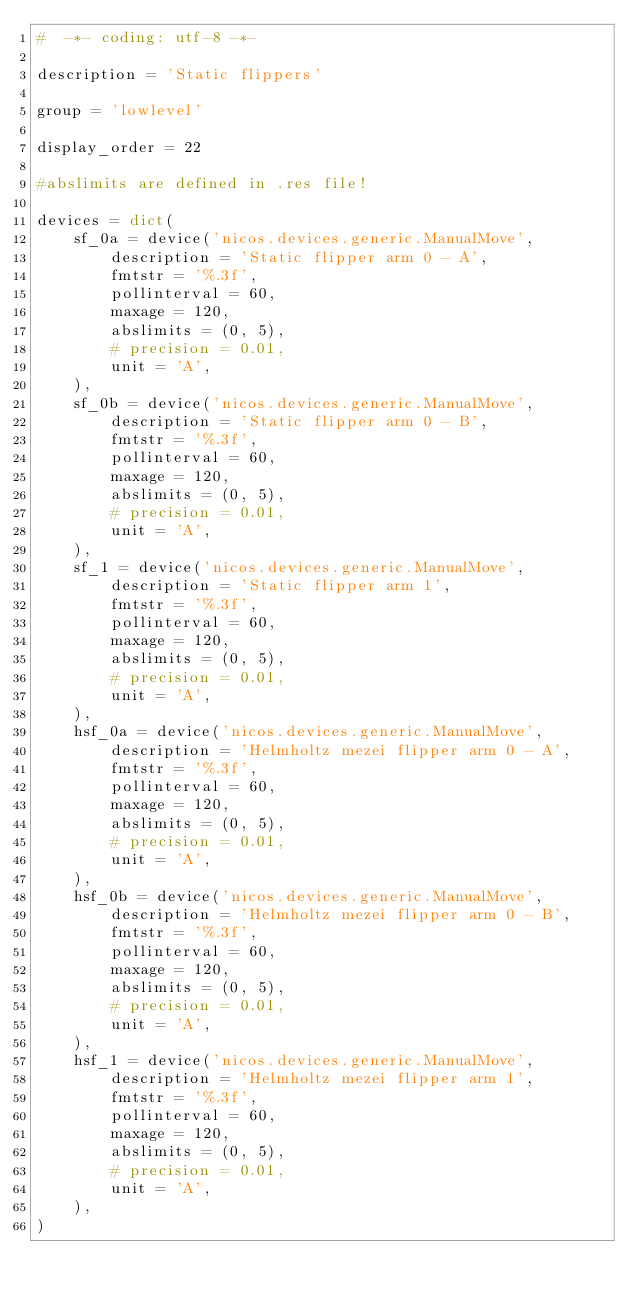<code> <loc_0><loc_0><loc_500><loc_500><_Python_>#  -*- coding: utf-8 -*-

description = 'Static flippers'

group = 'lowlevel'

display_order = 22

#abslimits are defined in .res file!

devices = dict(
    sf_0a = device('nicos.devices.generic.ManualMove',
        description = 'Static flipper arm 0 - A',
        fmtstr = '%.3f',
        pollinterval = 60,
        maxage = 120,
        abslimits = (0, 5),
        # precision = 0.01,
        unit = 'A',
    ),
    sf_0b = device('nicos.devices.generic.ManualMove',
        description = 'Static flipper arm 0 - B',
        fmtstr = '%.3f',
        pollinterval = 60,
        maxage = 120,
        abslimits = (0, 5),
        # precision = 0.01,
        unit = 'A',
    ),
    sf_1 = device('nicos.devices.generic.ManualMove',
        description = 'Static flipper arm 1',
        fmtstr = '%.3f',
        pollinterval = 60,
        maxage = 120,
        abslimits = (0, 5),
        # precision = 0.01,
        unit = 'A',
    ),
    hsf_0a = device('nicos.devices.generic.ManualMove',
        description = 'Helmholtz mezei flipper arm 0 - A',
        fmtstr = '%.3f',
        pollinterval = 60,
        maxage = 120,
        abslimits = (0, 5),
        # precision = 0.01,
        unit = 'A',
    ),
    hsf_0b = device('nicos.devices.generic.ManualMove',
        description = 'Helmholtz mezei flipper arm 0 - B',
        fmtstr = '%.3f',
        pollinterval = 60,
        maxage = 120,
        abslimits = (0, 5),
        # precision = 0.01,
        unit = 'A',
    ),
    hsf_1 = device('nicos.devices.generic.ManualMove',
        description = 'Helmholtz mezei flipper arm 1',
        fmtstr = '%.3f',
        pollinterval = 60,
        maxage = 120,
        abslimits = (0, 5),
        # precision = 0.01,
        unit = 'A',
    ),
)
</code> 